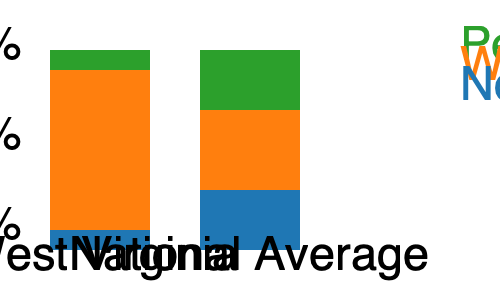Based on the stacked bar chart comparing the racial diversity of elected officials in West Virginia to national averages, approximately what percentage of West Virginia's elected officials are people of color? To answer this question, we need to analyze the stacked bar chart:

1. The left bar represents West Virginia's elected officials.
2. The right bar represents the national average.
3. Each bar is divided into three sections: Non-Hispanic White (blue), White (orange), and People of Color (green).
4. The percentage for each group is represented by the height of its section in the bar.

For West Virginia's bar:
1. The green section (People of Color) is at the top of the bar.
2. It occupies a very small portion of the entire bar.
3. By estimating the height of the green section relative to the total bar height, we can approximate the percentage.
4. The green section appears to take up about 10% of the bar's height.

Therefore, the percentage of elected officials in West Virginia who are people of color is approximately 10%.

This low percentage highlights the lack of racial diversity among elected officials in West Virginia compared to the national average, which shows a significantly larger portion of people of color (about 30%).
Answer: Approximately 10% 